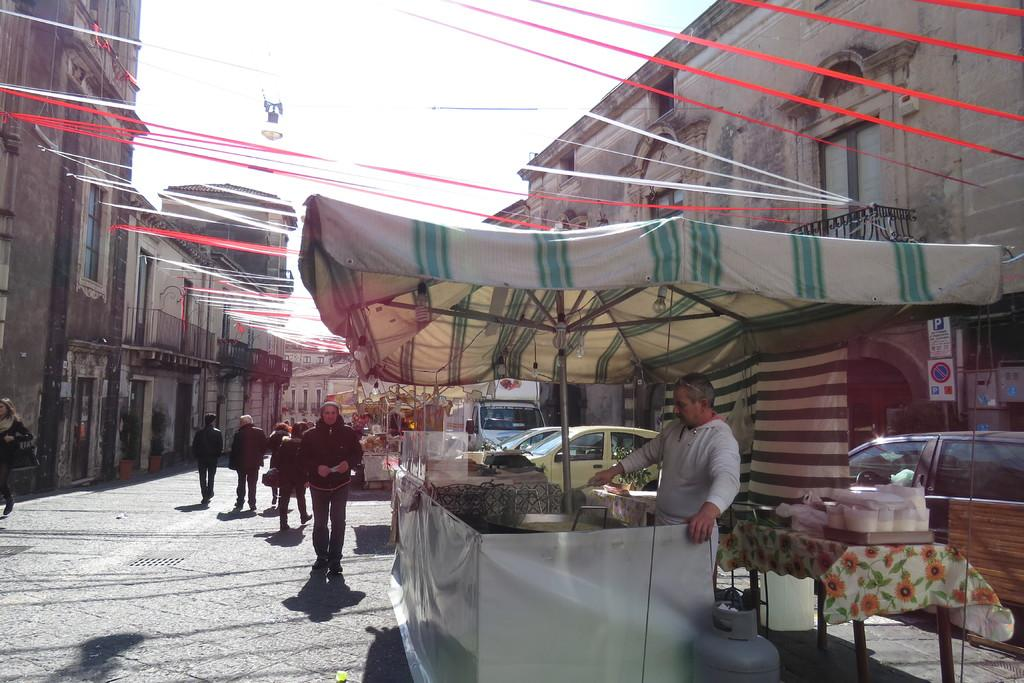What can be seen on the road in the image? There are vehicles and shops on the road in the image. What connects the buildings in the image? There are ribbons between the buildings in the image. What is hanging from one of the ribbons? A light is hanging from one of the ribbons in the image. What is visible in the background of the image? The sky is visible in the image. Can you see a frame around the image? The image itself does not have a frame, as the frame is not a part of the scene being depicted. Is there a bridge visible in the image? There is no bridge present in the image; it features vehicles, shops, ribbons, and a light. 